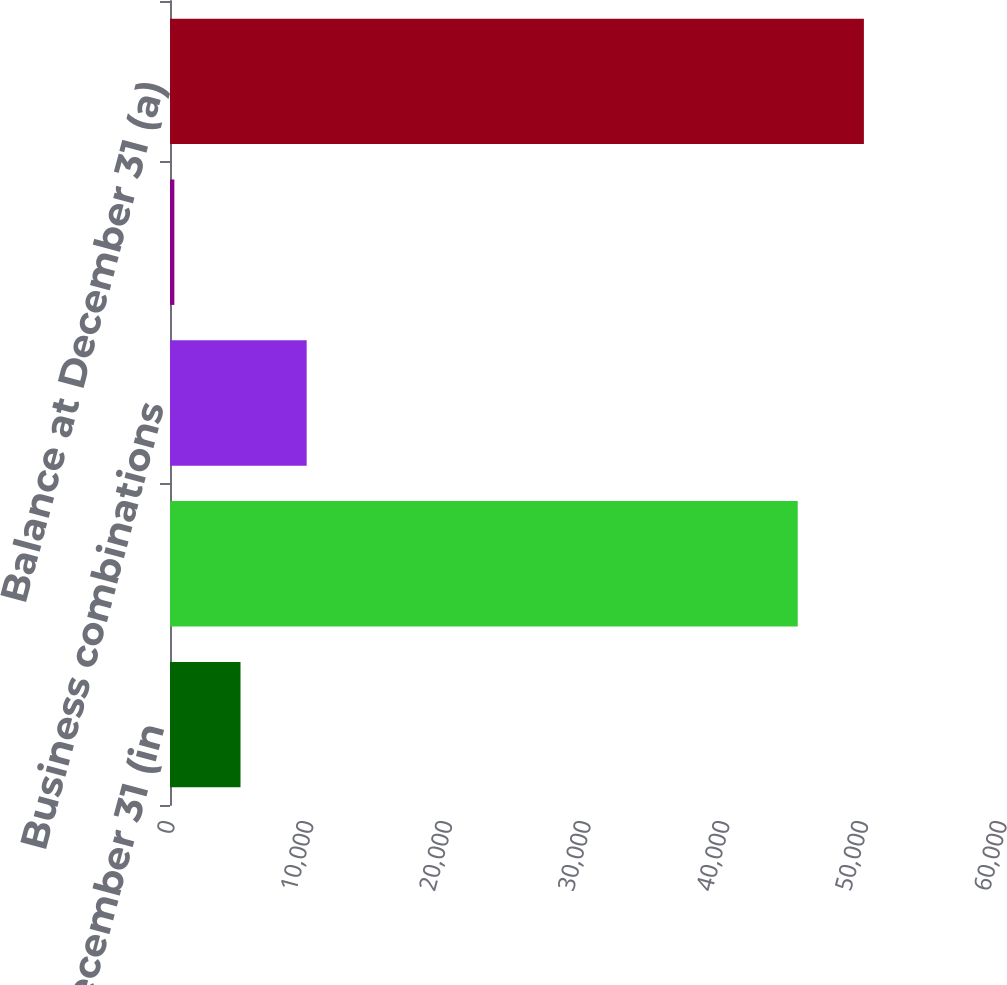Convert chart. <chart><loc_0><loc_0><loc_500><loc_500><bar_chart><fcel>Year ended December 31 (in<fcel>Beginning balance at January 1<fcel>Business combinations<fcel>Other (b)<fcel>Balance at December 31 (a)<nl><fcel>5085.3<fcel>45270<fcel>9856.6<fcel>314<fcel>50041.3<nl></chart> 